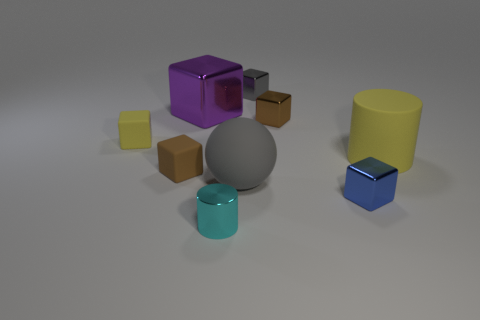Can you describe the texture and color of the purple object? The purple object has a smooth, almost reflective surface with a rich violet hue. It looks to be made out of a plastic or metallic material, given its lustrous appearance. 